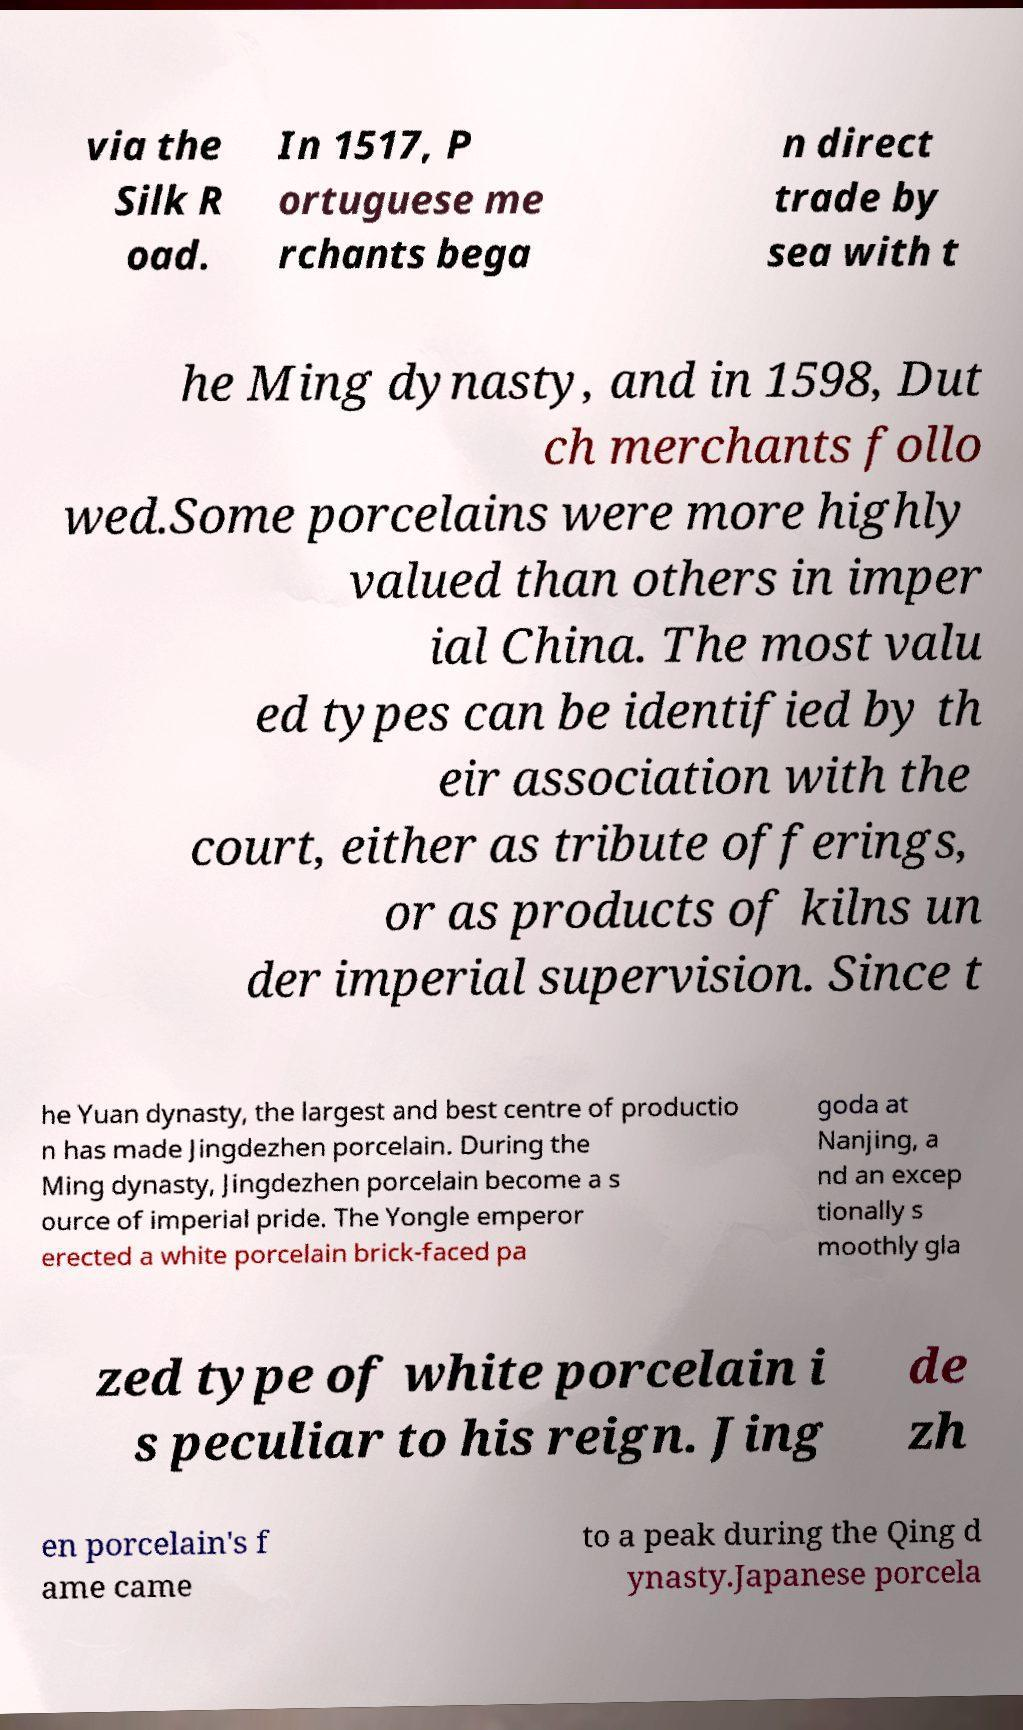Please identify and transcribe the text found in this image. via the Silk R oad. In 1517, P ortuguese me rchants bega n direct trade by sea with t he Ming dynasty, and in 1598, Dut ch merchants follo wed.Some porcelains were more highly valued than others in imper ial China. The most valu ed types can be identified by th eir association with the court, either as tribute offerings, or as products of kilns un der imperial supervision. Since t he Yuan dynasty, the largest and best centre of productio n has made Jingdezhen porcelain. During the Ming dynasty, Jingdezhen porcelain become a s ource of imperial pride. The Yongle emperor erected a white porcelain brick-faced pa goda at Nanjing, a nd an excep tionally s moothly gla zed type of white porcelain i s peculiar to his reign. Jing de zh en porcelain's f ame came to a peak during the Qing d ynasty.Japanese porcela 